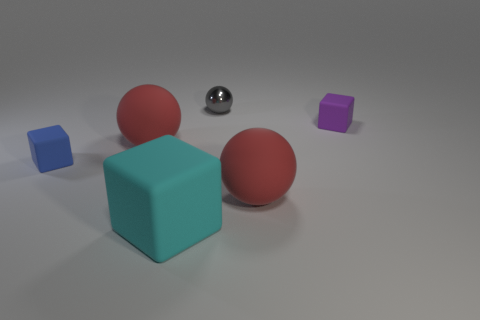What number of red rubber cubes have the same size as the blue matte block? 0 